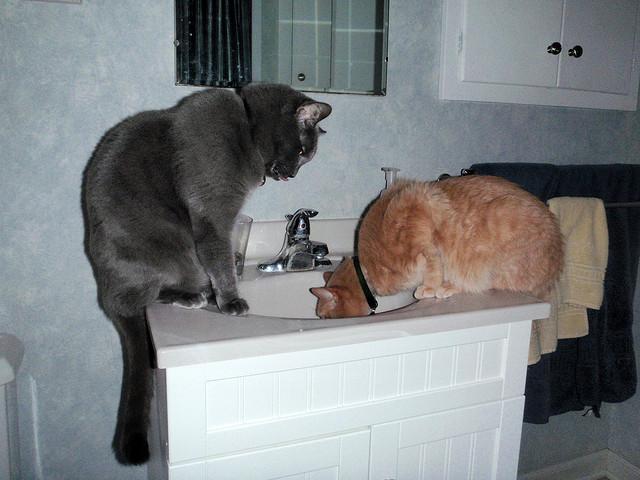Why is the cat's head in the sink?
Keep it brief. Drinking. What animal is shown?
Write a very short answer. Cat. Where is the brown cat's head?
Be succinct. Sink. Is the cat dehydrated?
Keep it brief. Yes. Are both cats the same color?
Give a very brief answer. No. Is there more than one cat?
Keep it brief. Yes. What animals are these?
Answer briefly. Cats. 